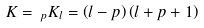Convert formula to latex. <formula><loc_0><loc_0><loc_500><loc_500>K = \, _ { p } K _ { l } = \left ( l - p \right ) \left ( l + p + 1 \right )</formula> 